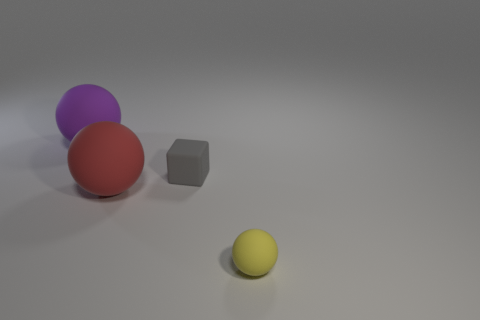Judging by the shadows, from which direction is the light source coming? The shadows in the image are cast toward the bottom right, implying that the light source is located toward the upper left side of the composition. 